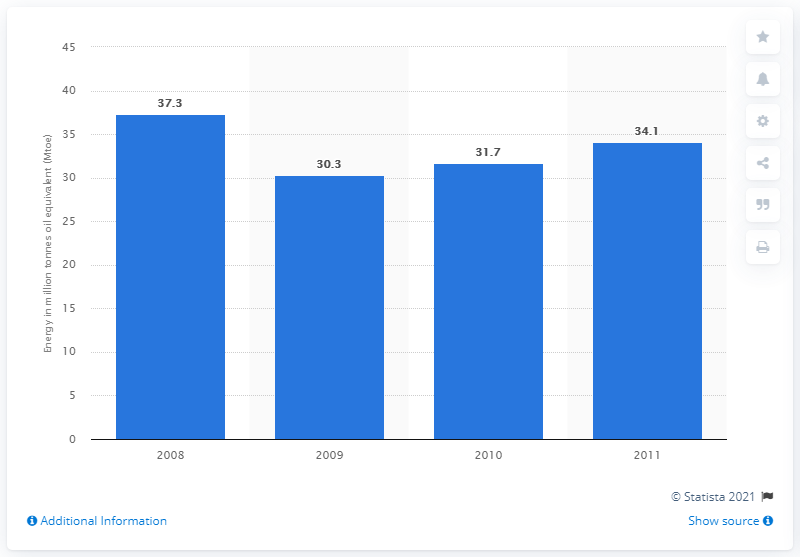Indicate a few pertinent items in this graphic. In 2009, the agri-food sector used approximately 30.3 gigajoules of energy. In 2008, the energy use in the agri-food sector was measured at 37.3 TWh. 